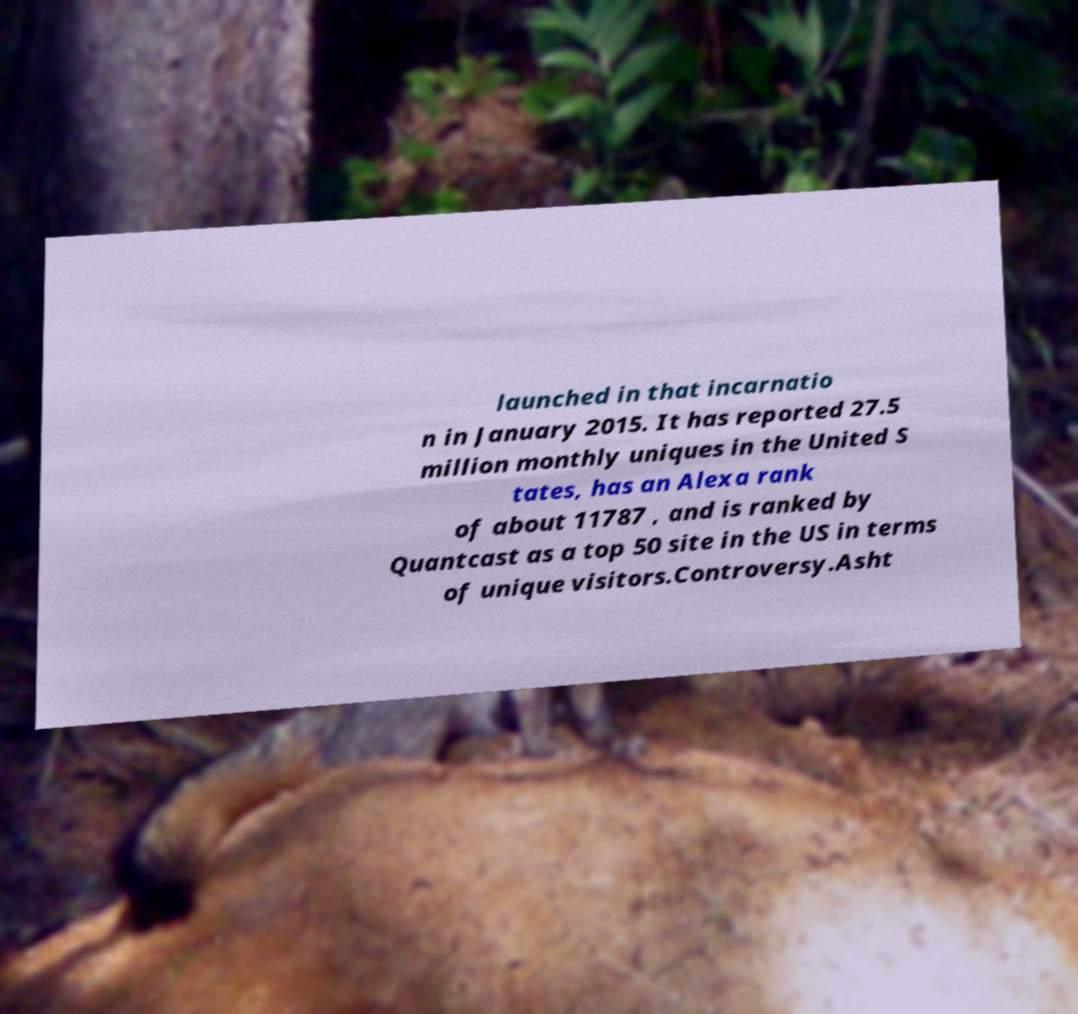Can you read and provide the text displayed in the image?This photo seems to have some interesting text. Can you extract and type it out for me? launched in that incarnatio n in January 2015. It has reported 27.5 million monthly uniques in the United S tates, has an Alexa rank of about 11787 , and is ranked by Quantcast as a top 50 site in the US in terms of unique visitors.Controversy.Asht 